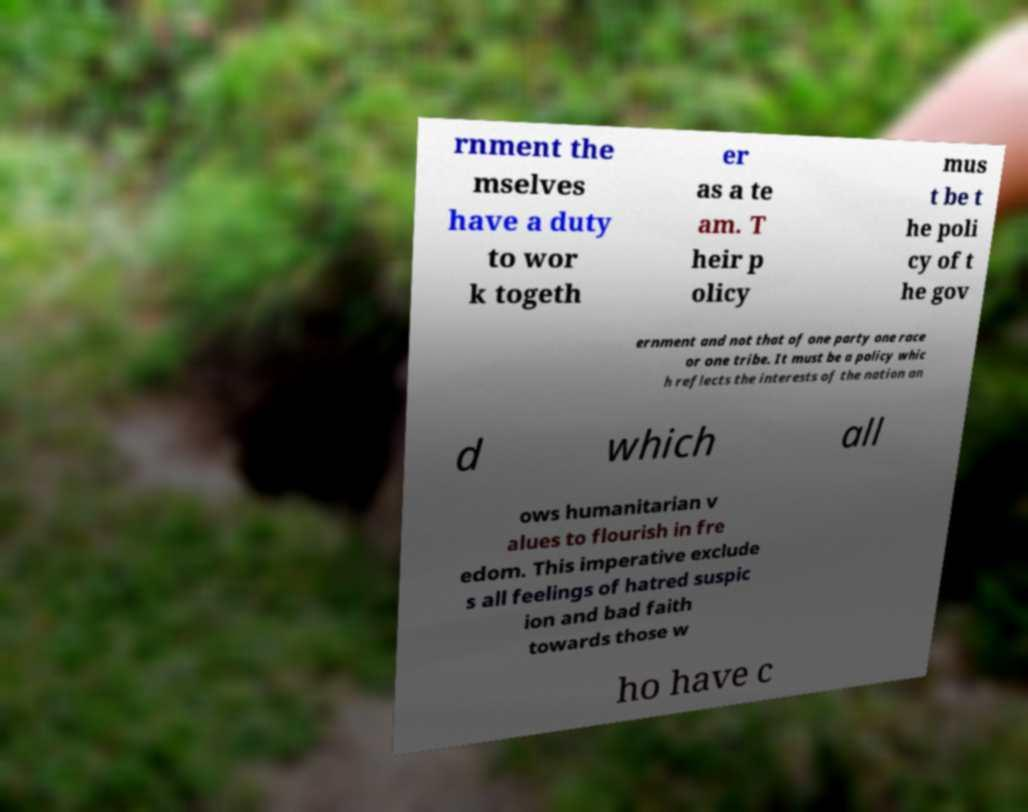There's text embedded in this image that I need extracted. Can you transcribe it verbatim? rnment the mselves have a duty to wor k togeth er as a te am. T heir p olicy mus t be t he poli cy of t he gov ernment and not that of one party one race or one tribe. It must be a policy whic h reflects the interests of the nation an d which all ows humanitarian v alues to flourish in fre edom. This imperative exclude s all feelings of hatred suspic ion and bad faith towards those w ho have c 